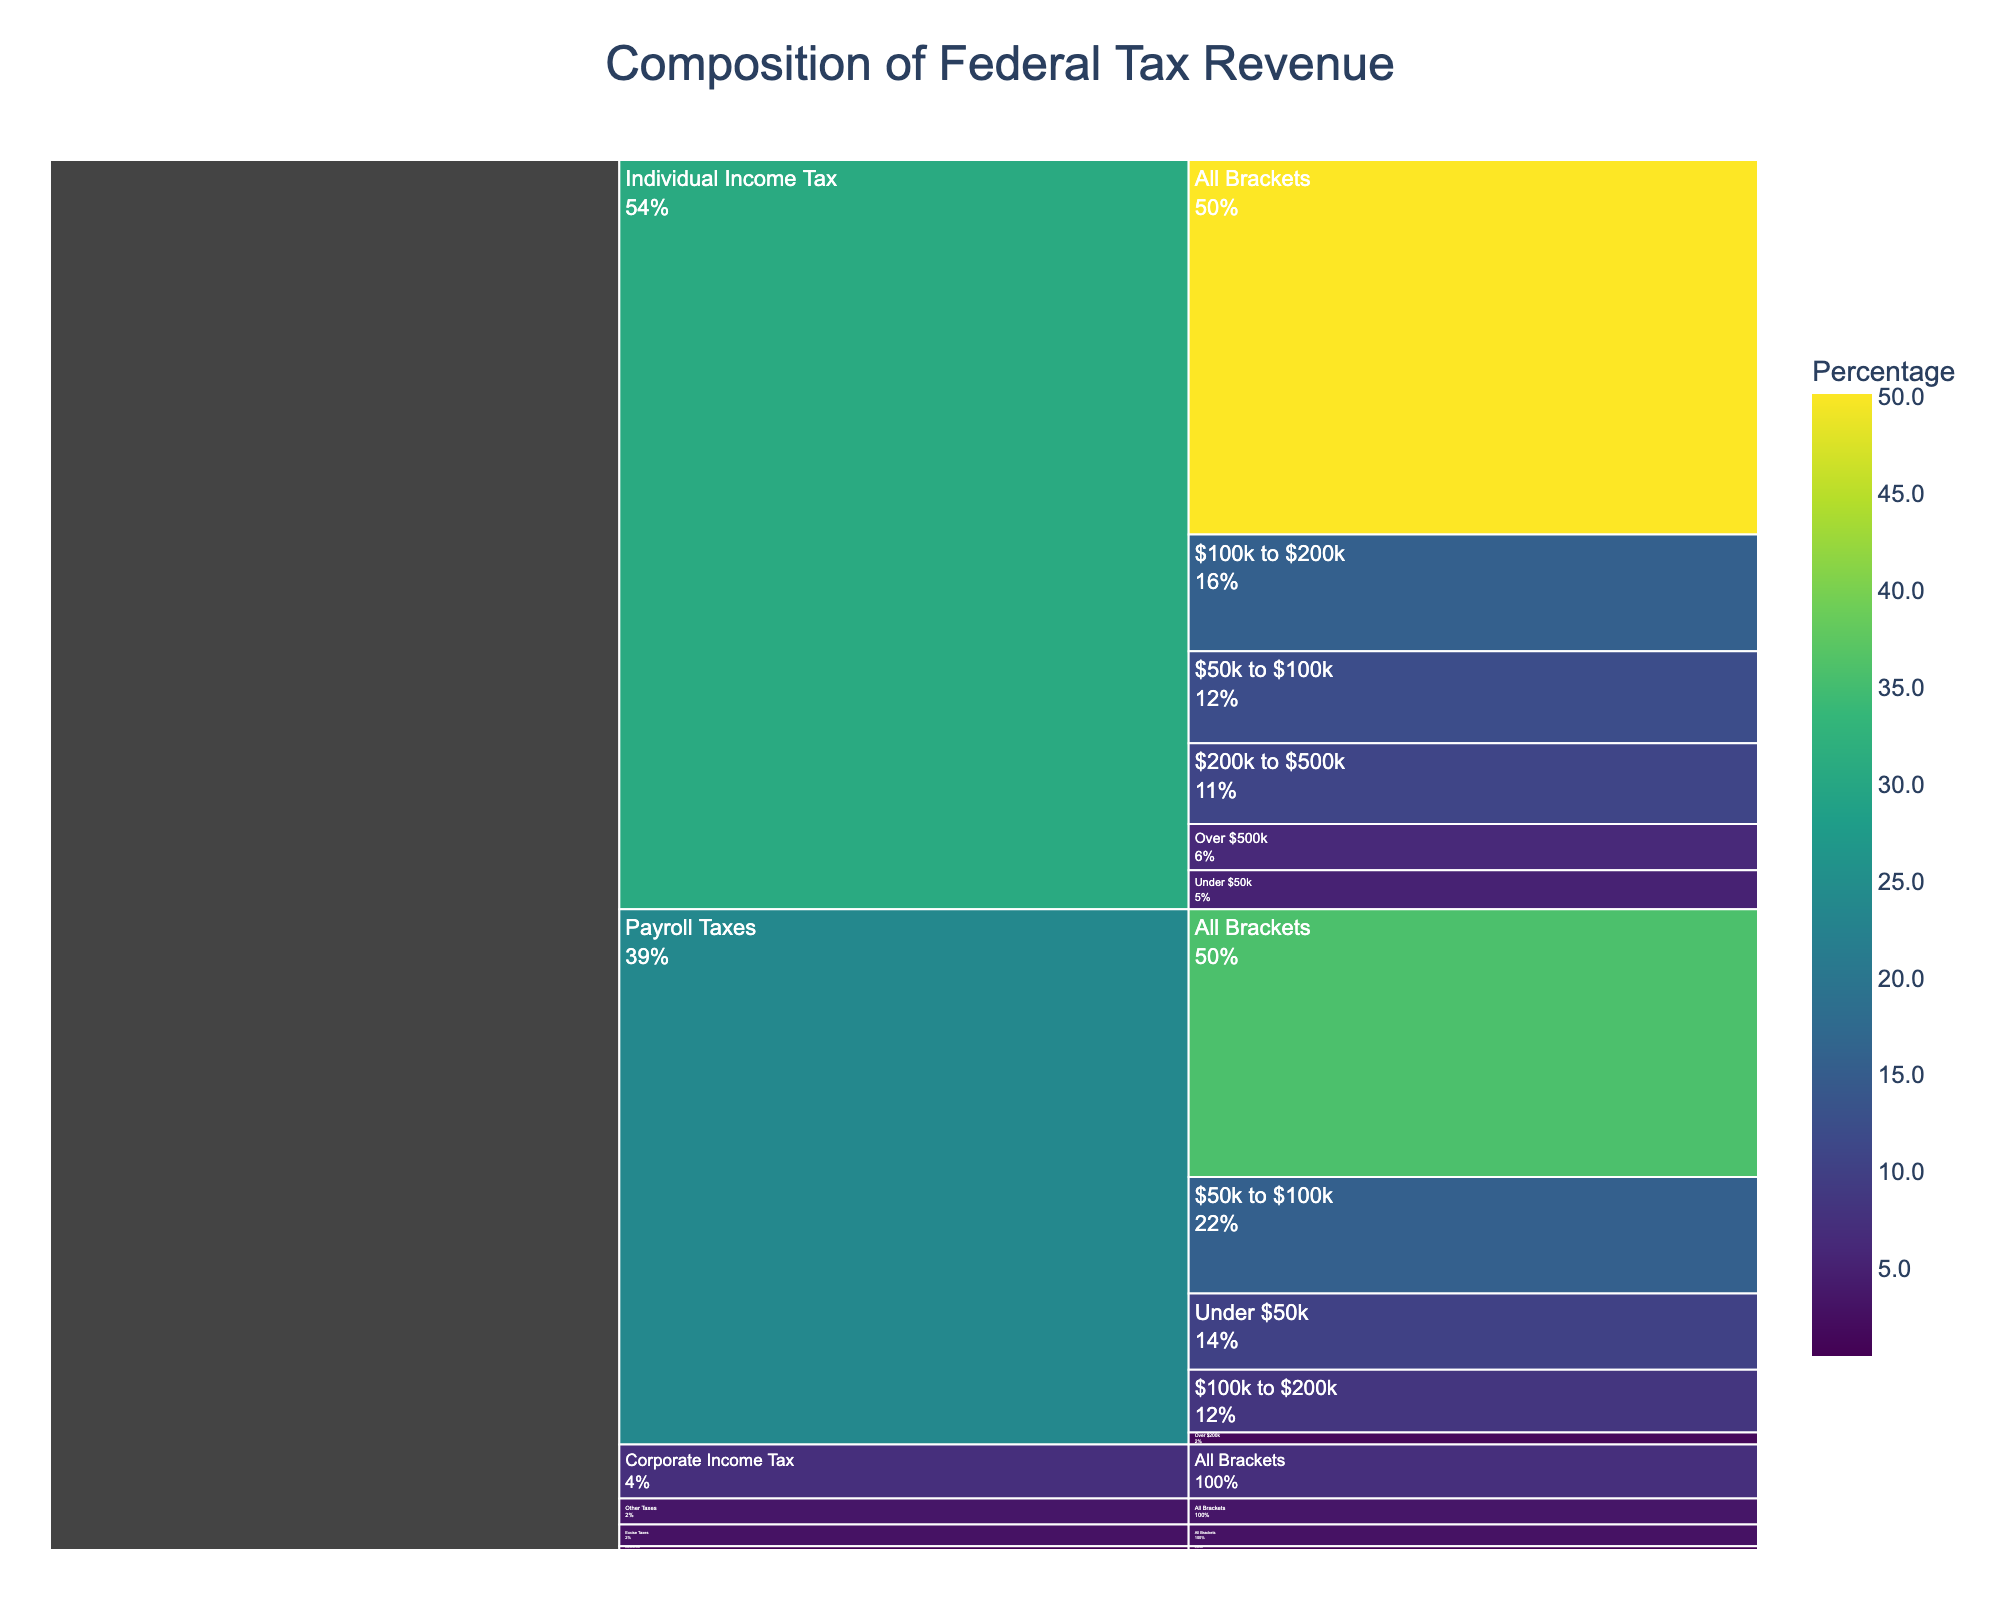What is the largest contributor to federal tax revenue from the given categories? The largest contributor can be identified by observing the tallest or most expansive segment in the chart. The "Individual Income Tax" category covers the biggest portion, indicating it contributes the most.
Answer: Individual Income Tax Which income bracket contributes the least to the federal tax revenue from individual income tax? By looking at the segments under "Individual Income Tax," you can see that "Under $50k" has the smallest percentage.
Answer: Under $50k How are payroll taxes distributed among different income brackets? By examining the branches under "Payroll Taxes," you can see the respective percentages: 10.2% for "Under $50k," 15.6% for "$50k to $100k," 8.4% for "$100k to $200k," and 1.6% for "Over $200k."
Answer: 10.2%, 15.6%, 8.4%, 1.6% Which tax type contributes the smallest percentage to the federal tax revenue? By looking at the smaller segments in the chart, "Estate and Gift Taxes" with 0.5% can be identified as the smallest contributor.
Answer: Estate and Gift Taxes What is the total contribution of tax sources other than individual income tax and payroll taxes? To find this, sum up the percentages of "Corporate Income Tax" (7.2%), "Excise Taxes" (2.9%), "Estate and Gift Taxes" (0.5%), and "Other Taxes" (3.5%). The total is 7.2% + 2.9% + 0.5% + 3.5% = 14.1%.
Answer: 14.1% How does the contribution of payroll taxes for the "$50k to $100k" bracket compare to individual income taxes for the same bracket? Compare the percentages for both categories in the "$50k to $100k" bracket. Payroll taxes contribute 15.6%, while individual income taxes contribute 12.3%, so payroll taxes contribute more.
Answer: Payroll taxes contribute more What is the combined contribution of individual income tax from the "Over $500k" and "Under $50k" brackets? Sum the percentages for "Over $500k" (6.2%) and "Under $50k" (5.2%): 6.2% + 5.2% = 11.4%.
Answer: 11.4% What percentage of total tax revenue comes from income brackets over $200k for payroll taxes and individual income taxes combined? Add the contribution from payroll taxes "Over $200k" (1.6%) and individual income taxes "$200k to $500k" (10.8%) and "Over $500k" (6.2%): 1.6% + 10.8% + 6.2% = 18.6%.
Answer: 18.6% Which category under "Individual Income Tax" has the highest contribution, and what is the percentage? Look at the various segments under "Individual Income Tax" and find that "$100k to $200k" has the highest contribution at 15.6%.
Answer: $100k to $200k, 15.6% What is the total percentage of federal tax revenue contributed by the top two income brackets of individual income tax together? Sum the percentages for "$100k to $200k" (15.6%) and "$200k to $500k" (10.8%): 15.6% + 10.8% = 26.4%.
Answer: 26.4% 